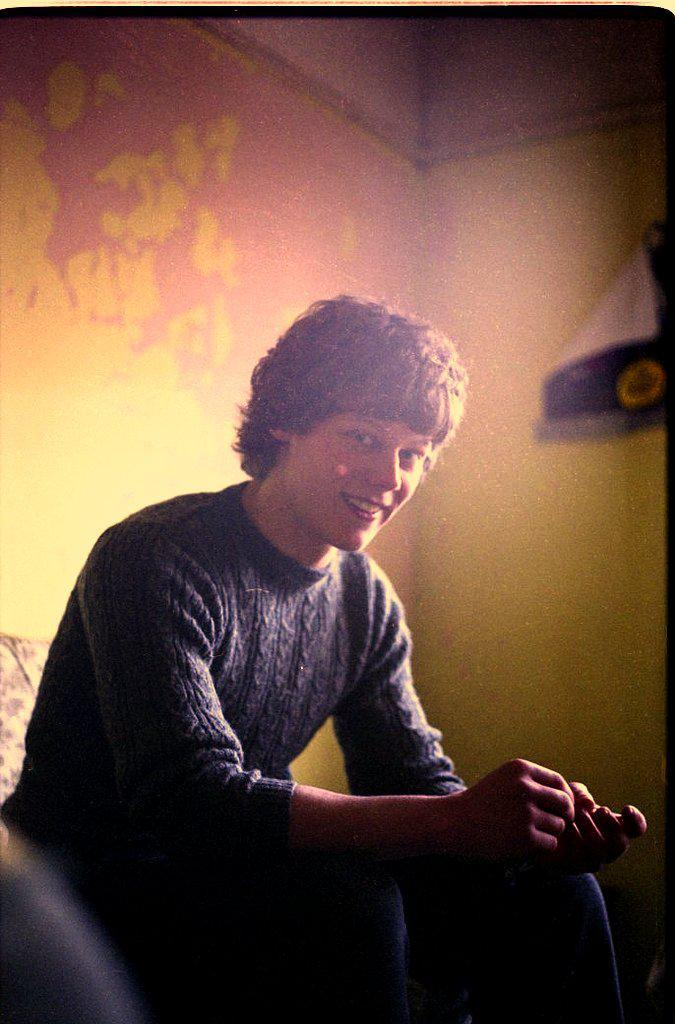What is the person in the image doing? The person is sitting on a sofa in the image. What can be seen in the background of the image? There is a wall in the background of the image. How many fish are swimming in the air above the person in the image? There are no fish present in the image, and the person is not in a location where fish could be swimming in the air. 